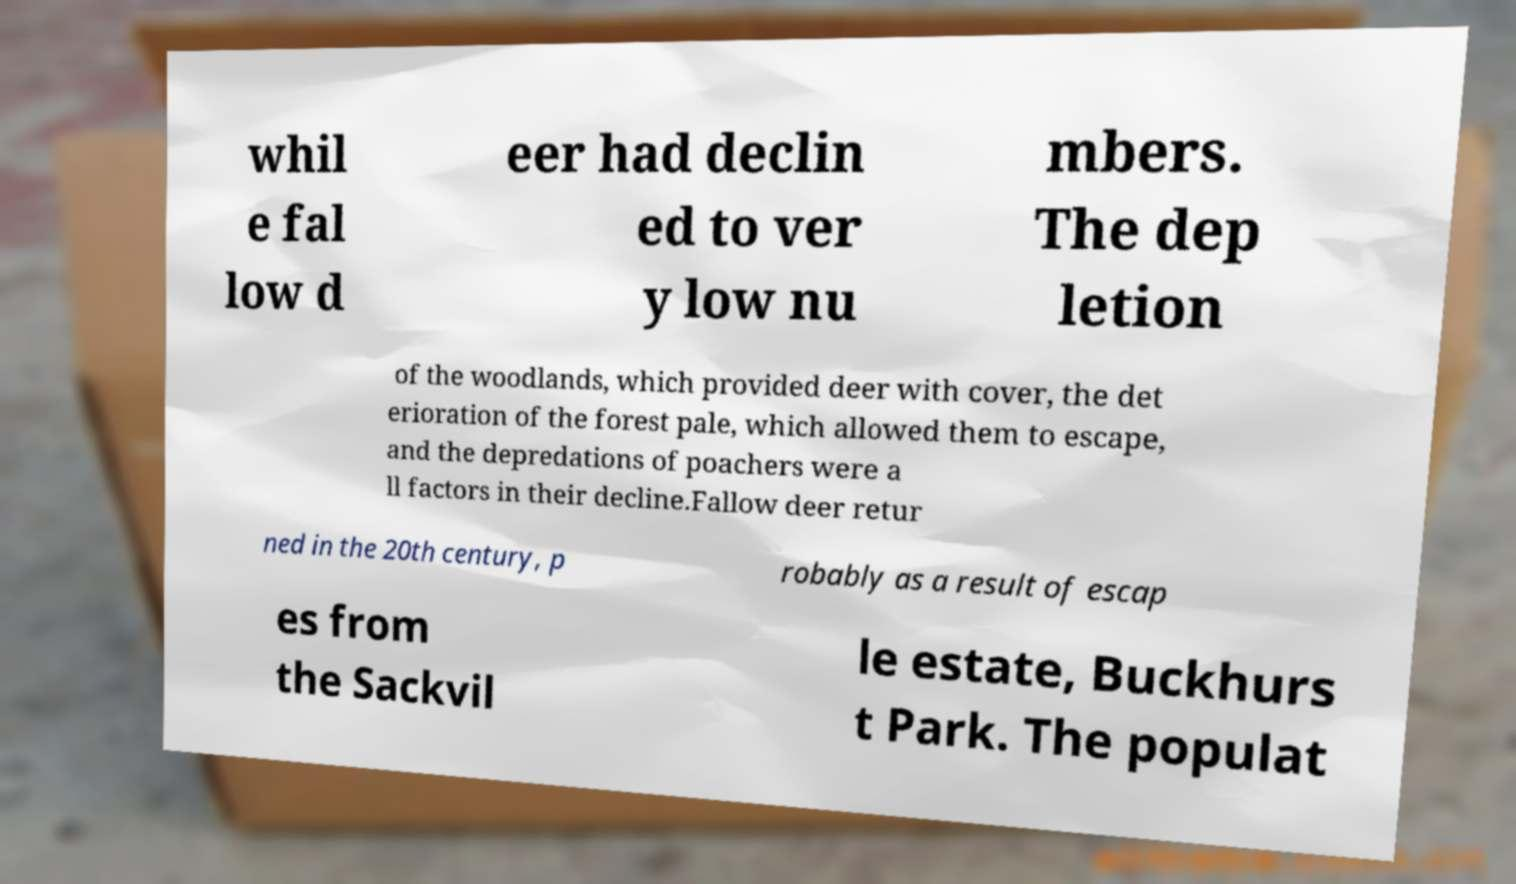Could you extract and type out the text from this image? whil e fal low d eer had declin ed to ver y low nu mbers. The dep letion of the woodlands, which provided deer with cover, the det erioration of the forest pale, which allowed them to escape, and the depredations of poachers were a ll factors in their decline.Fallow deer retur ned in the 20th century, p robably as a result of escap es from the Sackvil le estate, Buckhurs t Park. The populat 